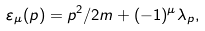Convert formula to latex. <formula><loc_0><loc_0><loc_500><loc_500>\varepsilon _ { \mu } ( p ) = p ^ { 2 } / 2 m + ( - 1 ) ^ { \mu } \lambda _ { p } ,</formula> 